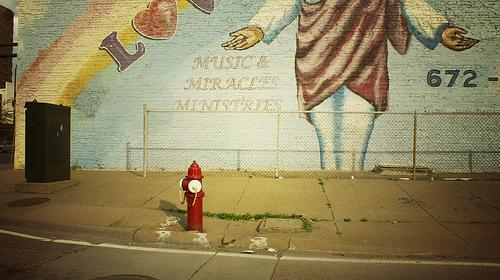Question: what numbers are on the wall?
Choices:
A. 672.
B. 543.
C. 289.
D. 983.
Answer with the letter. Answer: A Question: what words are under the hand?
Choices:
A. Lyrics.
B. Music and miracle ministries.
C. Song titles.
D. Prayers.
Answer with the letter. Answer: B Question: where is the rainbow?
Choices:
A. Sky.
B. Ceiling.
C. Heaven.
D. Wall.
Answer with the letter. Answer: D Question: what is growing in the cracks of the sidewalk?
Choices:
A. Weeds.
B. Mushrooms.
C. Flowers.
D. Grass.
Answer with the letter. Answer: D Question: where was the photo taken?
Choices:
A. Steet.
B. On the sidewalk.
C. Outdoors.
D. Crosswalk.
Answer with the letter. Answer: B 